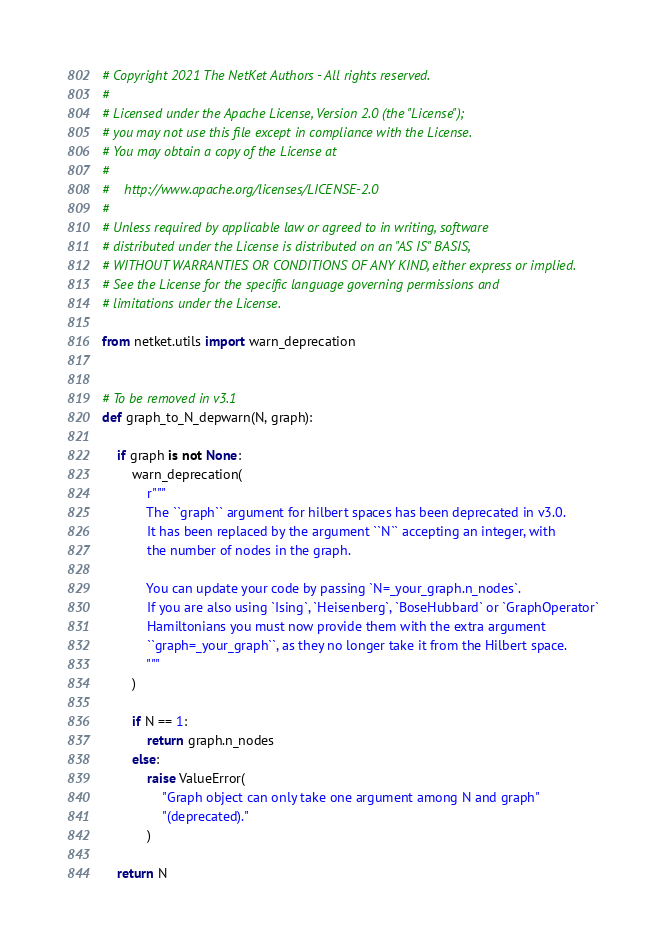<code> <loc_0><loc_0><loc_500><loc_500><_Python_># Copyright 2021 The NetKet Authors - All rights reserved.
#
# Licensed under the Apache License, Version 2.0 (the "License");
# you may not use this file except in compliance with the License.
# You may obtain a copy of the License at
#
#    http://www.apache.org/licenses/LICENSE-2.0
#
# Unless required by applicable law or agreed to in writing, software
# distributed under the License is distributed on an "AS IS" BASIS,
# WITHOUT WARRANTIES OR CONDITIONS OF ANY KIND, either express or implied.
# See the License for the specific language governing permissions and
# limitations under the License.

from netket.utils import warn_deprecation


# To be removed in v3.1
def graph_to_N_depwarn(N, graph):

    if graph is not None:
        warn_deprecation(
            r"""
            The ``graph`` argument for hilbert spaces has been deprecated in v3.0.
            It has been replaced by the argument ``N`` accepting an integer, with
            the number of nodes in the graph.

            You can update your code by passing `N=_your_graph.n_nodes`.
            If you are also using `Ising`, `Heisenberg`, `BoseHubbard` or `GraphOperator`
            Hamiltonians you must now provide them with the extra argument
            ``graph=_your_graph``, as they no longer take it from the Hilbert space.
            """
        )

        if N == 1:
            return graph.n_nodes
        else:
            raise ValueError(
                "Graph object can only take one argument among N and graph"
                "(deprecated)."
            )

    return N
</code> 